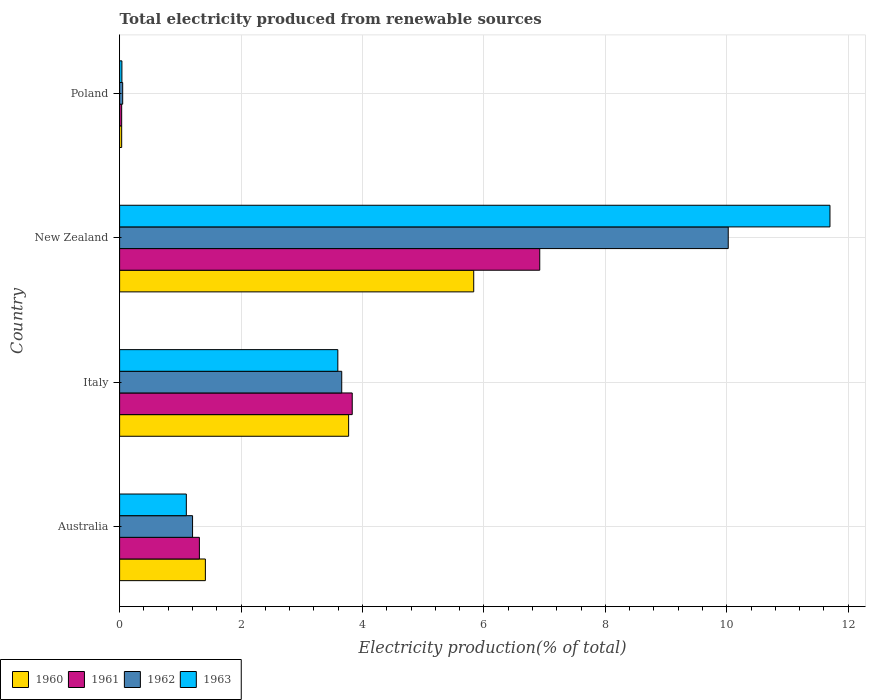Are the number of bars on each tick of the Y-axis equal?
Provide a succinct answer. Yes. How many bars are there on the 1st tick from the top?
Your response must be concise. 4. What is the label of the 4th group of bars from the top?
Offer a terse response. Australia. What is the total electricity produced in 1960 in Australia?
Provide a succinct answer. 1.41. Across all countries, what is the maximum total electricity produced in 1960?
Your response must be concise. 5.83. Across all countries, what is the minimum total electricity produced in 1961?
Your response must be concise. 0.03. In which country was the total electricity produced in 1961 maximum?
Keep it short and to the point. New Zealand. In which country was the total electricity produced in 1963 minimum?
Keep it short and to the point. Poland. What is the total total electricity produced in 1960 in the graph?
Provide a succinct answer. 11.05. What is the difference between the total electricity produced in 1963 in Australia and that in Poland?
Provide a succinct answer. 1.06. What is the difference between the total electricity produced in 1961 in Poland and the total electricity produced in 1962 in Australia?
Offer a very short reply. -1.17. What is the average total electricity produced in 1960 per country?
Your answer should be very brief. 2.76. What is the difference between the total electricity produced in 1961 and total electricity produced in 1963 in Poland?
Offer a very short reply. -0. In how many countries, is the total electricity produced in 1962 greater than 10.8 %?
Offer a very short reply. 0. What is the ratio of the total electricity produced in 1961 in Italy to that in New Zealand?
Give a very brief answer. 0.55. Is the total electricity produced in 1962 in Australia less than that in Italy?
Ensure brevity in your answer.  Yes. Is the difference between the total electricity produced in 1961 in New Zealand and Poland greater than the difference between the total electricity produced in 1963 in New Zealand and Poland?
Keep it short and to the point. No. What is the difference between the highest and the second highest total electricity produced in 1963?
Provide a short and direct response. 8.11. What is the difference between the highest and the lowest total electricity produced in 1960?
Keep it short and to the point. 5.8. Is it the case that in every country, the sum of the total electricity produced in 1961 and total electricity produced in 1962 is greater than the total electricity produced in 1963?
Provide a short and direct response. Yes. How many bars are there?
Give a very brief answer. 16. How many countries are there in the graph?
Your answer should be compact. 4. What is the title of the graph?
Your answer should be compact. Total electricity produced from renewable sources. Does "1968" appear as one of the legend labels in the graph?
Give a very brief answer. No. What is the label or title of the X-axis?
Provide a short and direct response. Electricity production(% of total). What is the label or title of the Y-axis?
Your answer should be compact. Country. What is the Electricity production(% of total) of 1960 in Australia?
Your answer should be very brief. 1.41. What is the Electricity production(% of total) of 1961 in Australia?
Your answer should be very brief. 1.31. What is the Electricity production(% of total) of 1962 in Australia?
Keep it short and to the point. 1.2. What is the Electricity production(% of total) of 1963 in Australia?
Give a very brief answer. 1.1. What is the Electricity production(% of total) of 1960 in Italy?
Your answer should be compact. 3.77. What is the Electricity production(% of total) in 1961 in Italy?
Offer a very short reply. 3.83. What is the Electricity production(% of total) of 1962 in Italy?
Offer a terse response. 3.66. What is the Electricity production(% of total) of 1963 in Italy?
Offer a very short reply. 3.59. What is the Electricity production(% of total) of 1960 in New Zealand?
Offer a terse response. 5.83. What is the Electricity production(% of total) of 1961 in New Zealand?
Your response must be concise. 6.92. What is the Electricity production(% of total) in 1962 in New Zealand?
Offer a terse response. 10.02. What is the Electricity production(% of total) in 1963 in New Zealand?
Offer a terse response. 11.7. What is the Electricity production(% of total) in 1960 in Poland?
Give a very brief answer. 0.03. What is the Electricity production(% of total) in 1961 in Poland?
Make the answer very short. 0.03. What is the Electricity production(% of total) of 1962 in Poland?
Your response must be concise. 0.05. What is the Electricity production(% of total) in 1963 in Poland?
Provide a short and direct response. 0.04. Across all countries, what is the maximum Electricity production(% of total) in 1960?
Your answer should be very brief. 5.83. Across all countries, what is the maximum Electricity production(% of total) in 1961?
Your answer should be very brief. 6.92. Across all countries, what is the maximum Electricity production(% of total) in 1962?
Provide a succinct answer. 10.02. Across all countries, what is the maximum Electricity production(% of total) in 1963?
Your answer should be very brief. 11.7. Across all countries, what is the minimum Electricity production(% of total) of 1960?
Your answer should be very brief. 0.03. Across all countries, what is the minimum Electricity production(% of total) of 1961?
Keep it short and to the point. 0.03. Across all countries, what is the minimum Electricity production(% of total) in 1962?
Your response must be concise. 0.05. Across all countries, what is the minimum Electricity production(% of total) in 1963?
Keep it short and to the point. 0.04. What is the total Electricity production(% of total) in 1960 in the graph?
Offer a terse response. 11.05. What is the total Electricity production(% of total) of 1962 in the graph?
Your answer should be very brief. 14.94. What is the total Electricity production(% of total) in 1963 in the graph?
Provide a short and direct response. 16.43. What is the difference between the Electricity production(% of total) of 1960 in Australia and that in Italy?
Provide a succinct answer. -2.36. What is the difference between the Electricity production(% of total) of 1961 in Australia and that in Italy?
Ensure brevity in your answer.  -2.52. What is the difference between the Electricity production(% of total) in 1962 in Australia and that in Italy?
Offer a very short reply. -2.46. What is the difference between the Electricity production(% of total) of 1963 in Australia and that in Italy?
Your answer should be compact. -2.5. What is the difference between the Electricity production(% of total) of 1960 in Australia and that in New Zealand?
Provide a succinct answer. -4.42. What is the difference between the Electricity production(% of total) of 1961 in Australia and that in New Zealand?
Your answer should be compact. -5.61. What is the difference between the Electricity production(% of total) in 1962 in Australia and that in New Zealand?
Your answer should be compact. -8.82. What is the difference between the Electricity production(% of total) in 1963 in Australia and that in New Zealand?
Make the answer very short. -10.6. What is the difference between the Electricity production(% of total) of 1960 in Australia and that in Poland?
Your answer should be compact. 1.38. What is the difference between the Electricity production(% of total) in 1961 in Australia and that in Poland?
Keep it short and to the point. 1.28. What is the difference between the Electricity production(% of total) of 1962 in Australia and that in Poland?
Your response must be concise. 1.15. What is the difference between the Electricity production(% of total) of 1963 in Australia and that in Poland?
Your answer should be very brief. 1.06. What is the difference between the Electricity production(% of total) of 1960 in Italy and that in New Zealand?
Your answer should be very brief. -2.06. What is the difference between the Electricity production(% of total) in 1961 in Italy and that in New Zealand?
Your answer should be very brief. -3.09. What is the difference between the Electricity production(% of total) of 1962 in Italy and that in New Zealand?
Your response must be concise. -6.37. What is the difference between the Electricity production(% of total) of 1963 in Italy and that in New Zealand?
Keep it short and to the point. -8.11. What is the difference between the Electricity production(% of total) in 1960 in Italy and that in Poland?
Ensure brevity in your answer.  3.74. What is the difference between the Electricity production(% of total) of 1961 in Italy and that in Poland?
Offer a very short reply. 3.8. What is the difference between the Electricity production(% of total) in 1962 in Italy and that in Poland?
Give a very brief answer. 3.61. What is the difference between the Electricity production(% of total) in 1963 in Italy and that in Poland?
Provide a short and direct response. 3.56. What is the difference between the Electricity production(% of total) of 1960 in New Zealand and that in Poland?
Keep it short and to the point. 5.8. What is the difference between the Electricity production(% of total) in 1961 in New Zealand and that in Poland?
Offer a very short reply. 6.89. What is the difference between the Electricity production(% of total) in 1962 in New Zealand and that in Poland?
Your answer should be compact. 9.97. What is the difference between the Electricity production(% of total) of 1963 in New Zealand and that in Poland?
Provide a succinct answer. 11.66. What is the difference between the Electricity production(% of total) in 1960 in Australia and the Electricity production(% of total) in 1961 in Italy?
Make the answer very short. -2.42. What is the difference between the Electricity production(% of total) in 1960 in Australia and the Electricity production(% of total) in 1962 in Italy?
Your answer should be compact. -2.25. What is the difference between the Electricity production(% of total) of 1960 in Australia and the Electricity production(% of total) of 1963 in Italy?
Keep it short and to the point. -2.18. What is the difference between the Electricity production(% of total) of 1961 in Australia and the Electricity production(% of total) of 1962 in Italy?
Offer a very short reply. -2.34. What is the difference between the Electricity production(% of total) of 1961 in Australia and the Electricity production(% of total) of 1963 in Italy?
Offer a very short reply. -2.28. What is the difference between the Electricity production(% of total) in 1962 in Australia and the Electricity production(% of total) in 1963 in Italy?
Your answer should be compact. -2.39. What is the difference between the Electricity production(% of total) of 1960 in Australia and the Electricity production(% of total) of 1961 in New Zealand?
Your response must be concise. -5.51. What is the difference between the Electricity production(% of total) of 1960 in Australia and the Electricity production(% of total) of 1962 in New Zealand?
Offer a terse response. -8.61. What is the difference between the Electricity production(% of total) of 1960 in Australia and the Electricity production(% of total) of 1963 in New Zealand?
Your answer should be compact. -10.29. What is the difference between the Electricity production(% of total) of 1961 in Australia and the Electricity production(% of total) of 1962 in New Zealand?
Offer a very short reply. -8.71. What is the difference between the Electricity production(% of total) of 1961 in Australia and the Electricity production(% of total) of 1963 in New Zealand?
Your answer should be very brief. -10.39. What is the difference between the Electricity production(% of total) of 1962 in Australia and the Electricity production(% of total) of 1963 in New Zealand?
Your response must be concise. -10.5. What is the difference between the Electricity production(% of total) in 1960 in Australia and the Electricity production(% of total) in 1961 in Poland?
Your response must be concise. 1.38. What is the difference between the Electricity production(% of total) of 1960 in Australia and the Electricity production(% of total) of 1962 in Poland?
Provide a succinct answer. 1.36. What is the difference between the Electricity production(% of total) in 1960 in Australia and the Electricity production(% of total) in 1963 in Poland?
Ensure brevity in your answer.  1.37. What is the difference between the Electricity production(% of total) of 1961 in Australia and the Electricity production(% of total) of 1962 in Poland?
Make the answer very short. 1.26. What is the difference between the Electricity production(% of total) of 1961 in Australia and the Electricity production(% of total) of 1963 in Poland?
Make the answer very short. 1.28. What is the difference between the Electricity production(% of total) in 1962 in Australia and the Electricity production(% of total) in 1963 in Poland?
Give a very brief answer. 1.16. What is the difference between the Electricity production(% of total) of 1960 in Italy and the Electricity production(% of total) of 1961 in New Zealand?
Your answer should be compact. -3.15. What is the difference between the Electricity production(% of total) in 1960 in Italy and the Electricity production(% of total) in 1962 in New Zealand?
Your response must be concise. -6.25. What is the difference between the Electricity production(% of total) in 1960 in Italy and the Electricity production(% of total) in 1963 in New Zealand?
Provide a succinct answer. -7.93. What is the difference between the Electricity production(% of total) of 1961 in Italy and the Electricity production(% of total) of 1962 in New Zealand?
Your response must be concise. -6.19. What is the difference between the Electricity production(% of total) of 1961 in Italy and the Electricity production(% of total) of 1963 in New Zealand?
Provide a short and direct response. -7.87. What is the difference between the Electricity production(% of total) of 1962 in Italy and the Electricity production(% of total) of 1963 in New Zealand?
Provide a short and direct response. -8.04. What is the difference between the Electricity production(% of total) of 1960 in Italy and the Electricity production(% of total) of 1961 in Poland?
Your answer should be compact. 3.74. What is the difference between the Electricity production(% of total) in 1960 in Italy and the Electricity production(% of total) in 1962 in Poland?
Keep it short and to the point. 3.72. What is the difference between the Electricity production(% of total) in 1960 in Italy and the Electricity production(% of total) in 1963 in Poland?
Make the answer very short. 3.73. What is the difference between the Electricity production(% of total) of 1961 in Italy and the Electricity production(% of total) of 1962 in Poland?
Ensure brevity in your answer.  3.78. What is the difference between the Electricity production(% of total) of 1961 in Italy and the Electricity production(% of total) of 1963 in Poland?
Offer a very short reply. 3.79. What is the difference between the Electricity production(% of total) in 1962 in Italy and the Electricity production(% of total) in 1963 in Poland?
Your answer should be compact. 3.62. What is the difference between the Electricity production(% of total) of 1960 in New Zealand and the Electricity production(% of total) of 1961 in Poland?
Ensure brevity in your answer.  5.8. What is the difference between the Electricity production(% of total) of 1960 in New Zealand and the Electricity production(% of total) of 1962 in Poland?
Your response must be concise. 5.78. What is the difference between the Electricity production(% of total) in 1960 in New Zealand and the Electricity production(% of total) in 1963 in Poland?
Provide a short and direct response. 5.79. What is the difference between the Electricity production(% of total) in 1961 in New Zealand and the Electricity production(% of total) in 1962 in Poland?
Make the answer very short. 6.87. What is the difference between the Electricity production(% of total) of 1961 in New Zealand and the Electricity production(% of total) of 1963 in Poland?
Your response must be concise. 6.88. What is the difference between the Electricity production(% of total) of 1962 in New Zealand and the Electricity production(% of total) of 1963 in Poland?
Keep it short and to the point. 9.99. What is the average Electricity production(% of total) in 1960 per country?
Give a very brief answer. 2.76. What is the average Electricity production(% of total) of 1961 per country?
Provide a short and direct response. 3.02. What is the average Electricity production(% of total) in 1962 per country?
Your response must be concise. 3.73. What is the average Electricity production(% of total) of 1963 per country?
Make the answer very short. 4.11. What is the difference between the Electricity production(% of total) of 1960 and Electricity production(% of total) of 1961 in Australia?
Ensure brevity in your answer.  0.1. What is the difference between the Electricity production(% of total) of 1960 and Electricity production(% of total) of 1962 in Australia?
Keep it short and to the point. 0.21. What is the difference between the Electricity production(% of total) of 1960 and Electricity production(% of total) of 1963 in Australia?
Your response must be concise. 0.31. What is the difference between the Electricity production(% of total) of 1961 and Electricity production(% of total) of 1962 in Australia?
Provide a short and direct response. 0.11. What is the difference between the Electricity production(% of total) in 1961 and Electricity production(% of total) in 1963 in Australia?
Provide a succinct answer. 0.21. What is the difference between the Electricity production(% of total) in 1962 and Electricity production(% of total) in 1963 in Australia?
Your response must be concise. 0.1. What is the difference between the Electricity production(% of total) in 1960 and Electricity production(% of total) in 1961 in Italy?
Your answer should be very brief. -0.06. What is the difference between the Electricity production(% of total) in 1960 and Electricity production(% of total) in 1962 in Italy?
Your response must be concise. 0.11. What is the difference between the Electricity production(% of total) in 1960 and Electricity production(% of total) in 1963 in Italy?
Offer a very short reply. 0.18. What is the difference between the Electricity production(% of total) in 1961 and Electricity production(% of total) in 1962 in Italy?
Your response must be concise. 0.17. What is the difference between the Electricity production(% of total) in 1961 and Electricity production(% of total) in 1963 in Italy?
Your response must be concise. 0.24. What is the difference between the Electricity production(% of total) in 1962 and Electricity production(% of total) in 1963 in Italy?
Your response must be concise. 0.06. What is the difference between the Electricity production(% of total) of 1960 and Electricity production(% of total) of 1961 in New Zealand?
Offer a very short reply. -1.09. What is the difference between the Electricity production(% of total) of 1960 and Electricity production(% of total) of 1962 in New Zealand?
Offer a very short reply. -4.19. What is the difference between the Electricity production(% of total) of 1960 and Electricity production(% of total) of 1963 in New Zealand?
Your response must be concise. -5.87. What is the difference between the Electricity production(% of total) of 1961 and Electricity production(% of total) of 1962 in New Zealand?
Keep it short and to the point. -3.1. What is the difference between the Electricity production(% of total) in 1961 and Electricity production(% of total) in 1963 in New Zealand?
Give a very brief answer. -4.78. What is the difference between the Electricity production(% of total) in 1962 and Electricity production(% of total) in 1963 in New Zealand?
Keep it short and to the point. -1.68. What is the difference between the Electricity production(% of total) of 1960 and Electricity production(% of total) of 1961 in Poland?
Give a very brief answer. 0. What is the difference between the Electricity production(% of total) of 1960 and Electricity production(% of total) of 1962 in Poland?
Make the answer very short. -0.02. What is the difference between the Electricity production(% of total) of 1960 and Electricity production(% of total) of 1963 in Poland?
Make the answer very short. -0. What is the difference between the Electricity production(% of total) in 1961 and Electricity production(% of total) in 1962 in Poland?
Provide a succinct answer. -0.02. What is the difference between the Electricity production(% of total) in 1961 and Electricity production(% of total) in 1963 in Poland?
Your answer should be very brief. -0. What is the difference between the Electricity production(% of total) of 1962 and Electricity production(% of total) of 1963 in Poland?
Offer a terse response. 0.01. What is the ratio of the Electricity production(% of total) in 1960 in Australia to that in Italy?
Your response must be concise. 0.37. What is the ratio of the Electricity production(% of total) in 1961 in Australia to that in Italy?
Give a very brief answer. 0.34. What is the ratio of the Electricity production(% of total) in 1962 in Australia to that in Italy?
Provide a succinct answer. 0.33. What is the ratio of the Electricity production(% of total) in 1963 in Australia to that in Italy?
Make the answer very short. 0.31. What is the ratio of the Electricity production(% of total) in 1960 in Australia to that in New Zealand?
Give a very brief answer. 0.24. What is the ratio of the Electricity production(% of total) of 1961 in Australia to that in New Zealand?
Provide a short and direct response. 0.19. What is the ratio of the Electricity production(% of total) of 1962 in Australia to that in New Zealand?
Offer a very short reply. 0.12. What is the ratio of the Electricity production(% of total) of 1963 in Australia to that in New Zealand?
Offer a very short reply. 0.09. What is the ratio of the Electricity production(% of total) in 1960 in Australia to that in Poland?
Offer a very short reply. 41.37. What is the ratio of the Electricity production(% of total) in 1961 in Australia to that in Poland?
Your answer should be compact. 38.51. What is the ratio of the Electricity production(% of total) in 1962 in Australia to that in Poland?
Offer a terse response. 23.61. What is the ratio of the Electricity production(% of total) in 1963 in Australia to that in Poland?
Ensure brevity in your answer.  29. What is the ratio of the Electricity production(% of total) of 1960 in Italy to that in New Zealand?
Ensure brevity in your answer.  0.65. What is the ratio of the Electricity production(% of total) of 1961 in Italy to that in New Zealand?
Your answer should be very brief. 0.55. What is the ratio of the Electricity production(% of total) of 1962 in Italy to that in New Zealand?
Keep it short and to the point. 0.36. What is the ratio of the Electricity production(% of total) in 1963 in Italy to that in New Zealand?
Your answer should be very brief. 0.31. What is the ratio of the Electricity production(% of total) of 1960 in Italy to that in Poland?
Offer a terse response. 110.45. What is the ratio of the Electricity production(% of total) of 1961 in Italy to that in Poland?
Ensure brevity in your answer.  112.3. What is the ratio of the Electricity production(% of total) of 1962 in Italy to that in Poland?
Offer a terse response. 71.88. What is the ratio of the Electricity production(% of total) of 1963 in Italy to that in Poland?
Provide a short and direct response. 94.84. What is the ratio of the Electricity production(% of total) of 1960 in New Zealand to that in Poland?
Your response must be concise. 170.79. What is the ratio of the Electricity production(% of total) of 1961 in New Zealand to that in Poland?
Offer a terse response. 202.83. What is the ratio of the Electricity production(% of total) in 1962 in New Zealand to that in Poland?
Ensure brevity in your answer.  196.95. What is the ratio of the Electricity production(% of total) of 1963 in New Zealand to that in Poland?
Keep it short and to the point. 308.73. What is the difference between the highest and the second highest Electricity production(% of total) of 1960?
Your answer should be very brief. 2.06. What is the difference between the highest and the second highest Electricity production(% of total) in 1961?
Keep it short and to the point. 3.09. What is the difference between the highest and the second highest Electricity production(% of total) in 1962?
Your answer should be very brief. 6.37. What is the difference between the highest and the second highest Electricity production(% of total) in 1963?
Provide a short and direct response. 8.11. What is the difference between the highest and the lowest Electricity production(% of total) in 1960?
Provide a short and direct response. 5.8. What is the difference between the highest and the lowest Electricity production(% of total) of 1961?
Your answer should be very brief. 6.89. What is the difference between the highest and the lowest Electricity production(% of total) in 1962?
Give a very brief answer. 9.97. What is the difference between the highest and the lowest Electricity production(% of total) in 1963?
Provide a succinct answer. 11.66. 